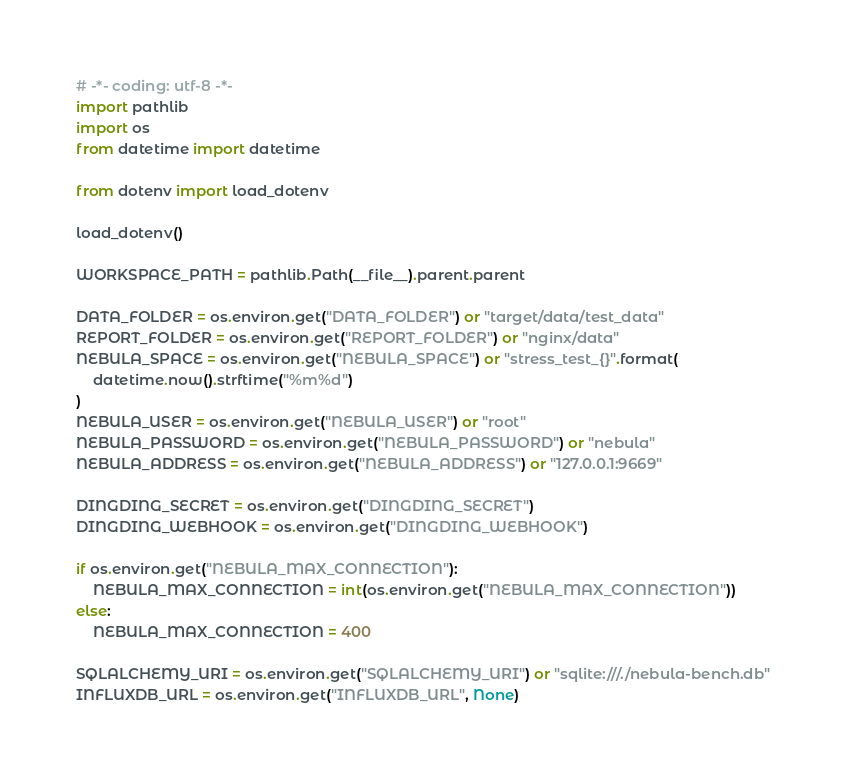<code> <loc_0><loc_0><loc_500><loc_500><_Python_># -*- coding: utf-8 -*-
import pathlib
import os
from datetime import datetime

from dotenv import load_dotenv

load_dotenv()

WORKSPACE_PATH = pathlib.Path(__file__).parent.parent

DATA_FOLDER = os.environ.get("DATA_FOLDER") or "target/data/test_data"
REPORT_FOLDER = os.environ.get("REPORT_FOLDER") or "nginx/data"
NEBULA_SPACE = os.environ.get("NEBULA_SPACE") or "stress_test_{}".format(
    datetime.now().strftime("%m%d")
)
NEBULA_USER = os.environ.get("NEBULA_USER") or "root"
NEBULA_PASSWORD = os.environ.get("NEBULA_PASSWORD") or "nebula"
NEBULA_ADDRESS = os.environ.get("NEBULA_ADDRESS") or "127.0.0.1:9669"

DINGDING_SECRET = os.environ.get("DINGDING_SECRET")
DINGDING_WEBHOOK = os.environ.get("DINGDING_WEBHOOK")

if os.environ.get("NEBULA_MAX_CONNECTION"):
    NEBULA_MAX_CONNECTION = int(os.environ.get("NEBULA_MAX_CONNECTION"))
else:
    NEBULA_MAX_CONNECTION = 400

SQLALCHEMY_URI = os.environ.get("SQLALCHEMY_URI") or "sqlite:///./nebula-bench.db"
INFLUXDB_URL = os.environ.get("INFLUXDB_URL", None)
</code> 